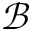Convert formula to latex. <formula><loc_0><loc_0><loc_500><loc_500>\mathcal { B }</formula> 